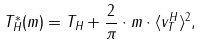Convert formula to latex. <formula><loc_0><loc_0><loc_500><loc_500>T ^ { * } _ { H } ( m ) = T _ { H } + \frac { 2 } { \pi } \cdot m \cdot \langle v ^ { H } _ { T } \rangle ^ { 2 } ,</formula> 